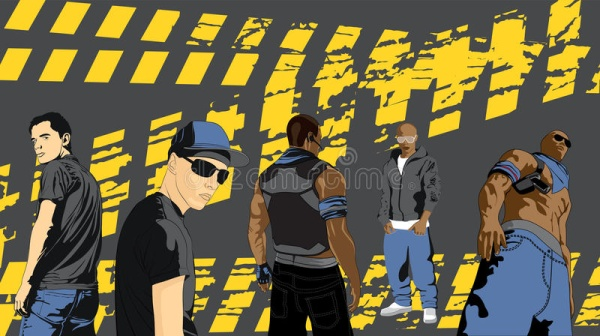Imagine you are interviewing these five men about their next big project together. What might they share? In an exclusive interview, the five men excitedly revealed details about their next big project: a global expedition to rediscover lost civilizations. Jason, the confident leader, explained their goal to uncover and preserve ancient cultural heritage sites. Tony, with his bold demeanor, described the dangers they are prepared to face during the journey, from extreme weather conditions to uncharted territories. Max, showcasing his usual mysterious nature, hinted at cryptic messages and hidden maps they have discovered that would guide their path. Chris, always the calm and collected one, shared how they plan to document their findings to educate future generations about the importance of preserving history. Luke, flexing his muscles, mentioned the rigorous physical training they are undergoing to prepare for the expedition's challenges. Together, their combined skills and unwavering camaraderie will lead them on an epic adventure into the unknown. 